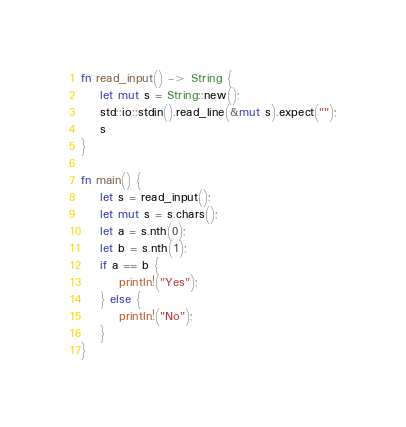Convert code to text. <code><loc_0><loc_0><loc_500><loc_500><_Rust_>fn read_input() -> String {
    let mut s = String::new();
    std::io::stdin().read_line(&mut s).expect("");
    s
}

fn main() {
    let s = read_input();
    let mut s = s.chars();
    let a = s.nth(0);
    let b = s.nth(1);
    if a == b {
        println!("Yes");
    } else {
        println!("No");
    }
}
</code> 